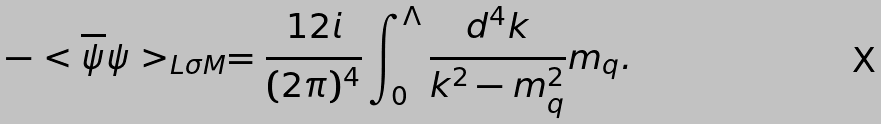Convert formula to latex. <formula><loc_0><loc_0><loc_500><loc_500>- < \overline { \psi } \psi > _ { L \sigma M } = \frac { 1 2 i } { ( 2 \pi ) ^ { 4 } } \int _ { 0 } ^ { \Lambda } \frac { d ^ { 4 } k } { k ^ { 2 } - m _ { q } ^ { 2 } } m _ { q } .</formula> 